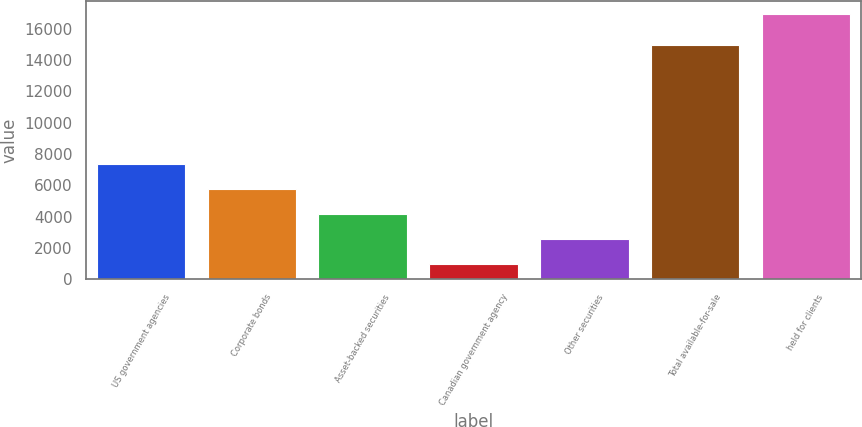Convert chart. <chart><loc_0><loc_0><loc_500><loc_500><bar_chart><fcel>US government agencies<fcel>Corporate bonds<fcel>Asset-backed securities<fcel>Canadian government agency<fcel>Other securities<fcel>Total available-for-sale<fcel>held for clients<nl><fcel>7380.3<fcel>5787.5<fcel>4194.7<fcel>1009.1<fcel>2601.9<fcel>14924.3<fcel>16937.1<nl></chart> 